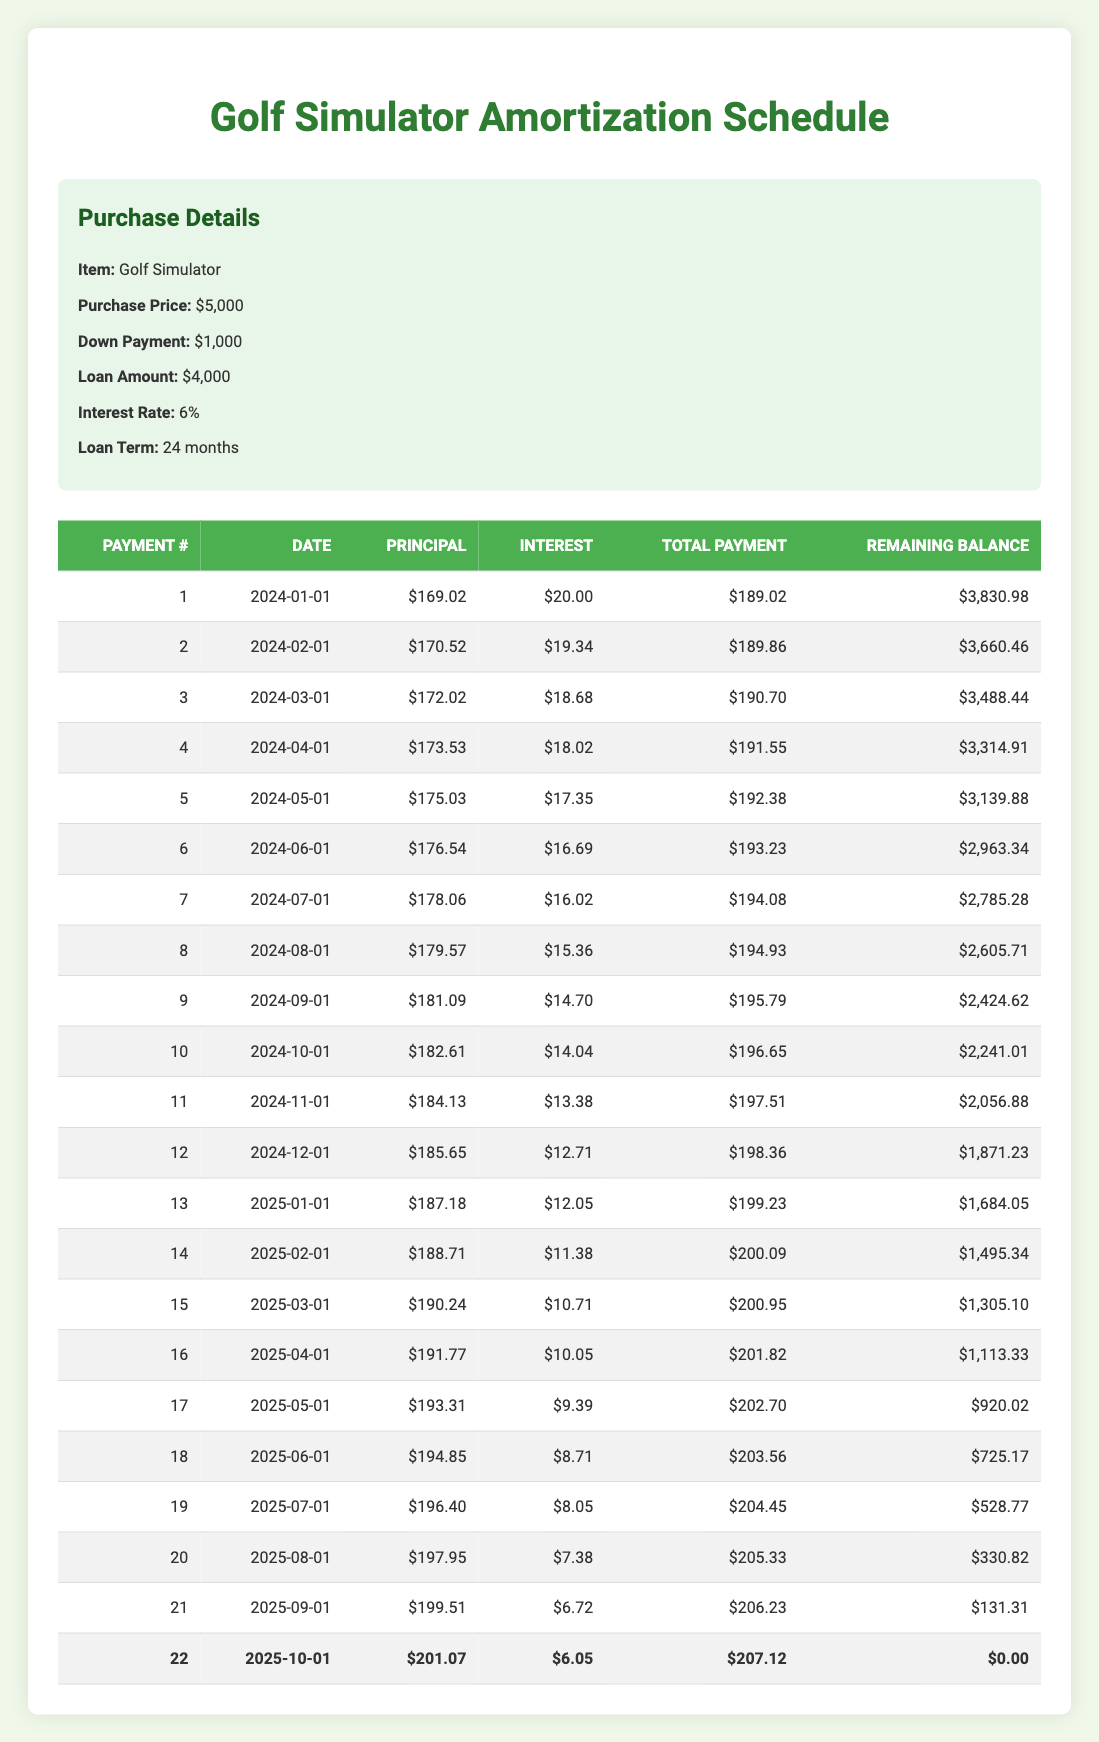What is the total amount paid by the end of the loan term? To find the total amount paid, we need to sum all the total payments from each month. The total payments are: 189.02 + 189.86 + 190.70 + 191.55 + 192.38 + 193.23 + 194.08 + 194.93 + 195.79 + 196.65 + 197.51 + 198.36 + 199.23 + 200.09 + 200.95 + 201.82 + 202.70 + 203.56 + 204.45 + 205.33 + 206.23 + 207.12 = 4,682.06
Answer: 4,682.06 What was the principal payment in the 10th month? The 10th month total payment shows a principal payment of 182.61. This value is directly found in the 10th row under the "Principal" column.
Answer: 182.61 How much did the interest payment decrease from the first month to the last month? The interest payment in the first month is 20.00, and in the last month (22nd payment) it is 6.05. To find the decrease: 20.00 - 6.05 = 13.95. Therefore, the interest payment decreased by 13.95 over the loan term.
Answer: 13.95 What is the remaining balance after the 12th payment? The remaining balance after the 12th payment is 1,871.23. This figure can be found in the "Remaining Balance" column corresponding to the 12th row.
Answer: 1,871.23 Did the total payment ever exceed 200 dollars in any month? Yes, there were total payments exceeding 200 dollars in multiple months. The payments from month 15 through the end all show amounts greater than 200.
Answer: Yes What is the average monthly principal payment over the entire loan term? The total principal paid over 24 months can be calculated by summing the principal payments: 169.02 + 170.52 + ... + 201.07. The total principal payment is approximately 4,500.82. To find the average, divide by 24 months: 4,500.82 / 24 = 187.536. Thus, the average monthly principal payment is approximately 187.54.
Answer: 187.54 How many payments had a total amount less than 195 dollars? By reviewing the total payment amounts in the schedule, we see that payments from months 1 to 9 had total amounts less than 195 dollars, giving us a total of 9 months.
Answer: 9 What is the difference in the remaining balance between the 5th and 15th payments? The remaining balance after the 5th payment is 3,139.88, and after the 15th is 1,305.10. To find the difference: 3,139.88 - 1,305.10 = 1,834.78. Therefore, the difference in remaining balance between these two payments is 1,834.78.
Answer: 1,834.78 